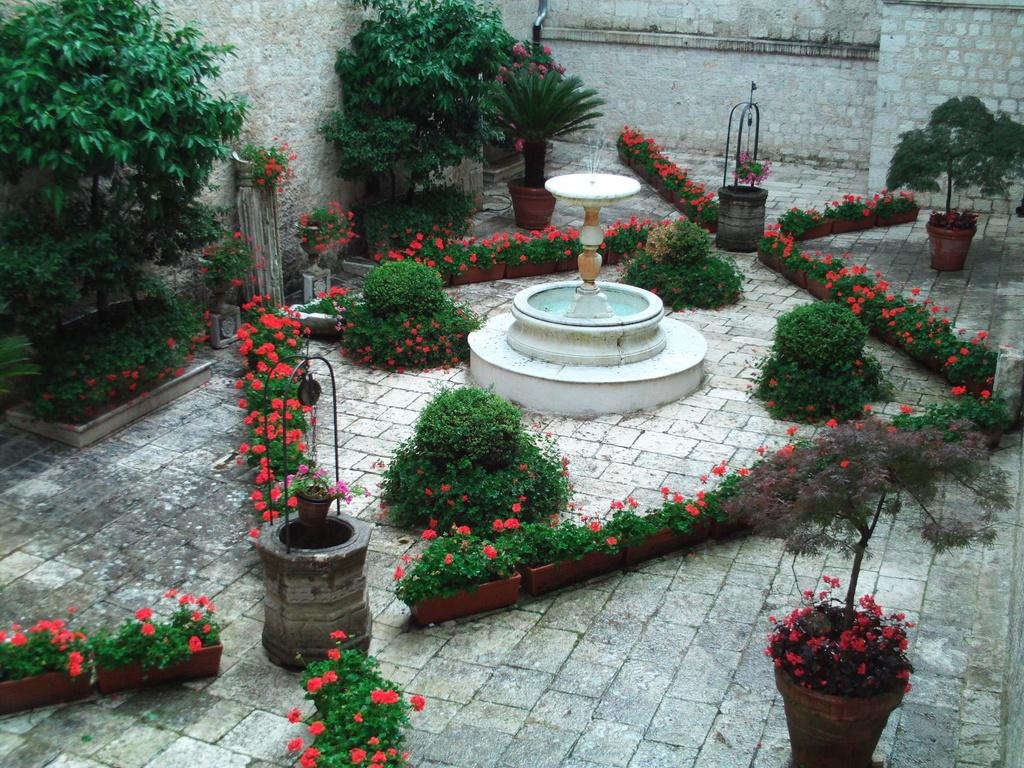What is the main feature in the image? There is a fountain in the image. What else can be seen in the image besides the fountain? There are plants and flowers in the image. What is visible in the background of the image? There is a wall in the background of the image. What is the opinion of the wheel about the fountain in the image? There is no wheel present in the image, and therefore it cannot have an opinion about the fountain. 